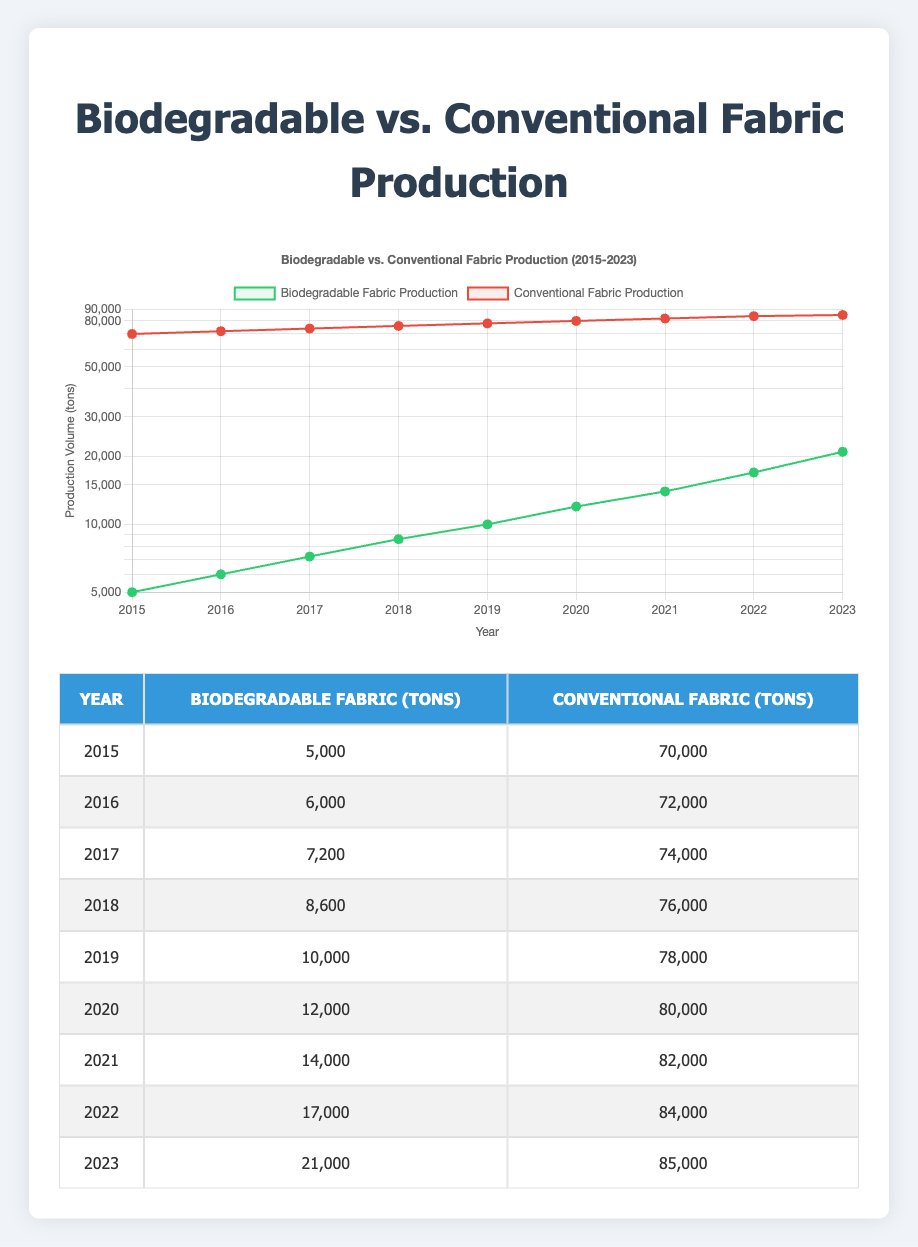What was the production volume of biodegradable fabric in 2020? The table shows that in the year 2020, the production volume of biodegradable fabric was listed as 12,000 tons.
Answer: 12,000 In which year did the biodegradable fabric production first exceed 10,000 tons? According to the table, biodegradable fabric production surpassed 10,000 tons in 2019, as 10,000 tons is the first value over that threshold.
Answer: 2019 What is the difference in production volume between conventional and biodegradable fabric in 2023? In the year 2023, the production volumes are 21,000 tons for biodegradable fabric and 85,000 tons for conventional fabric. The difference is 85,000 - 21,000 = 64,000 tons.
Answer: 64,000 What was the average production volume of conventional fabric from 2015 to 2023? The production volumes for conventional fabric from 2015 to 2023 are 70,000, 72,000, 74,000, 76,000, 78,000, 80,000, 82,000, 84,000, and 85,000 tons. Summing these values gives 70,000 + 72,000 + 74,000 + 76,000 + 78,000 + 80,000 + 82,000 + 84,000 + 85,000 =  605,000. Dividing by the 9 years gives an average of 605,000 / 9 = 67,222.22, which we round to 67,222.
Answer: 67,222 Is the production of biodegradable fabric greater than that of conventional fabric in any year? A review of the table shows that in every year from 2015 to 2023, the production of biodegradable fabric is significantly lower than that of conventional fabric, confirming that the statement is false.
Answer: No In which year did the conventional fabric production show the smallest increase compared to the previous year? By examining the values for conventional fabric, we see the following increases: 2,000 (2016-2015), 2,000 (2017-2016), 2,000 (2018-2017), 2,000 (2019-2018), 2,000 (2020-2019), 2,000 (2021-2020), 2,000 (2022-2021), and 1,000 (2023-2022). The smallest increase was in 2023, which was only 1,000 tons.
Answer: 2023 